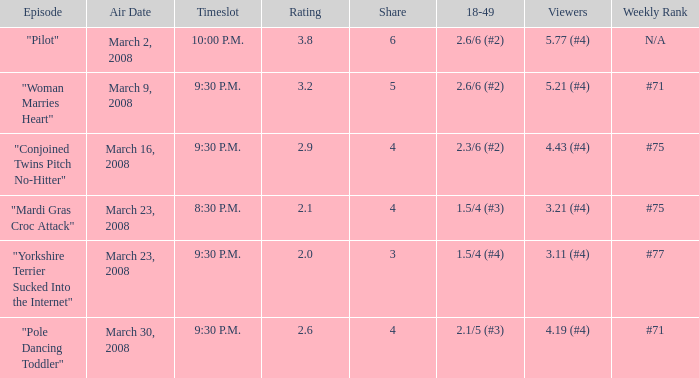What is the total ratings on share less than 4? 1.0. 